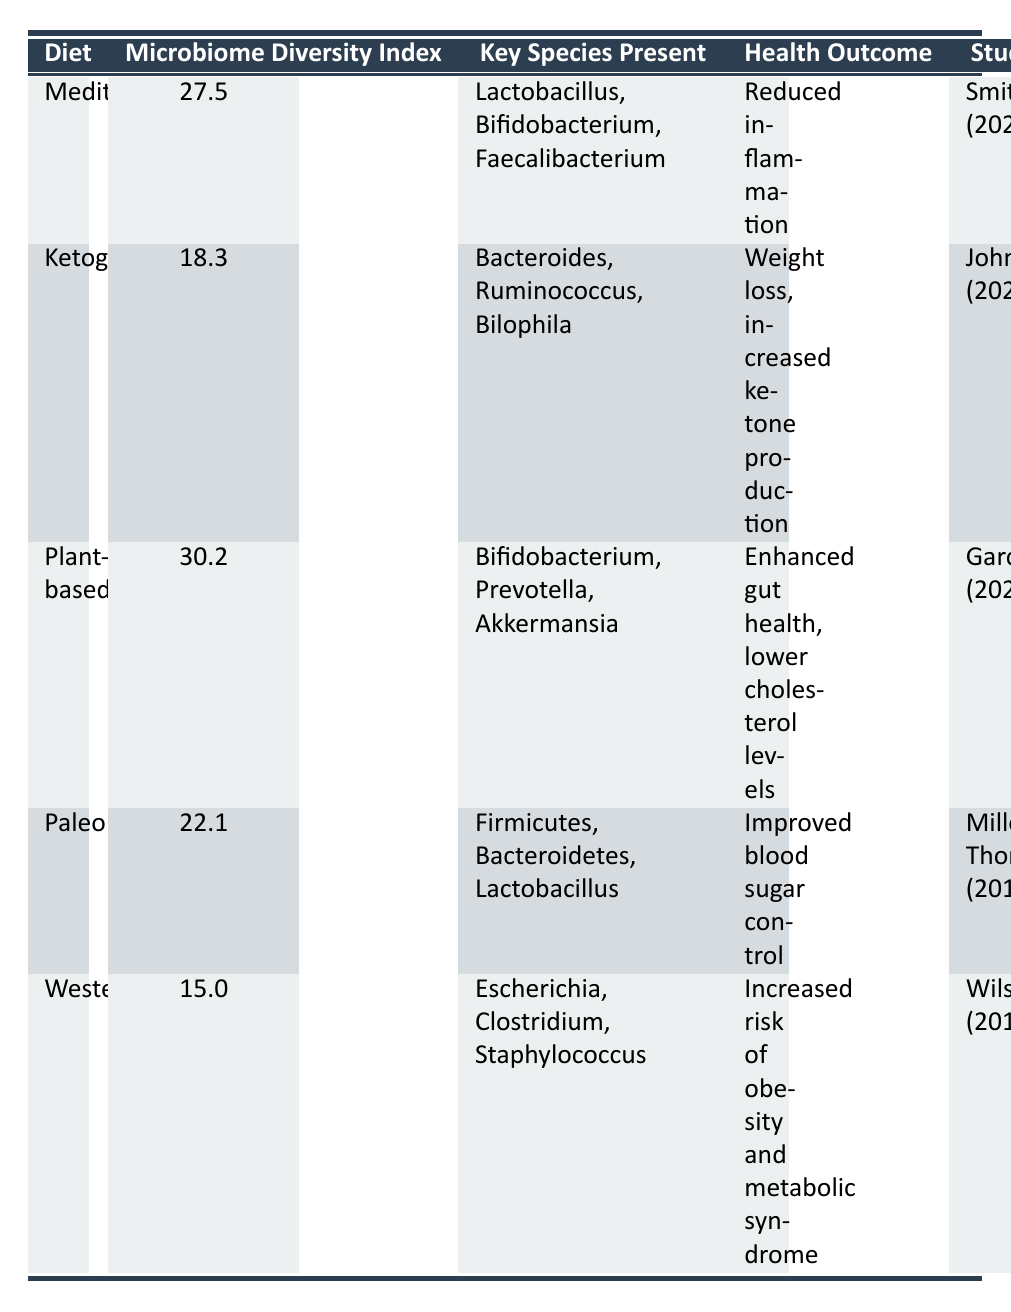What is the microbiome diversity index for the Mediterranean diet? From the table, the Mediterranean diet has a microbiome diversity index of 27.5.
Answer: 27.5 Which diet has the highest microbiome diversity index? The plant-based diet has the highest microbiome diversity index at 30.2, as seen in the table.
Answer: Plant-based Is Lactobacillus a key species present in the Mediterranean diet? Yes, Lactobacillus is listed as one of the key species present in the Mediterranean diet according to the table.
Answer: Yes What health outcome is associated with the Western diet? The table indicates that the Western diet is associated with an increased risk of obesity and metabolic syndrome.
Answer: Increased risk of obesity and metabolic syndrome What is the difference in microbiome diversity index between the Plant-based and Ketogenic diets? The microbiome diversity index for the Plant-based diet is 30.2 and for the Ketogenic diet, it is 18.3. The difference is 30.2 - 18.3 = 11.9.
Answer: 11.9 Which two diets are linked to improved health outcomes? The Mediterranean diet is linked to reduced inflammation, and the Paleo diet is linked to improved blood sugar control. This information can be found in the health outcome column of the table.
Answer: Mediterranean and Paleo Are there more key species present in the Plant-based diet compared to the Western diet? Yes, the Plant-based diet includes three key species: Bifidobacterium, Prevotella, and Akkermansia, while the Western diet lists three key species: Escherichia, Clostridium, and Staphylococcus. This confirms that both have the same number, but the richness of the species can differ.
Answer: Yes What can you conclude about the relationship between diet and microbiome diversity based on the table? The table suggests that diets like Plant-based and Mediterranean, which have higher microbiome diversity indices (30.2 and 27.5 respectively), are associated with positive health outcomes, while the Western diet, with the lowest diversity index (15.0), is linked to negative health outcomes such as the increased risk of obesity. This indicates a potential connection between higher microbiome diversity and better health outcomes.
Answer: Higher diversity associated with better health outcomes 